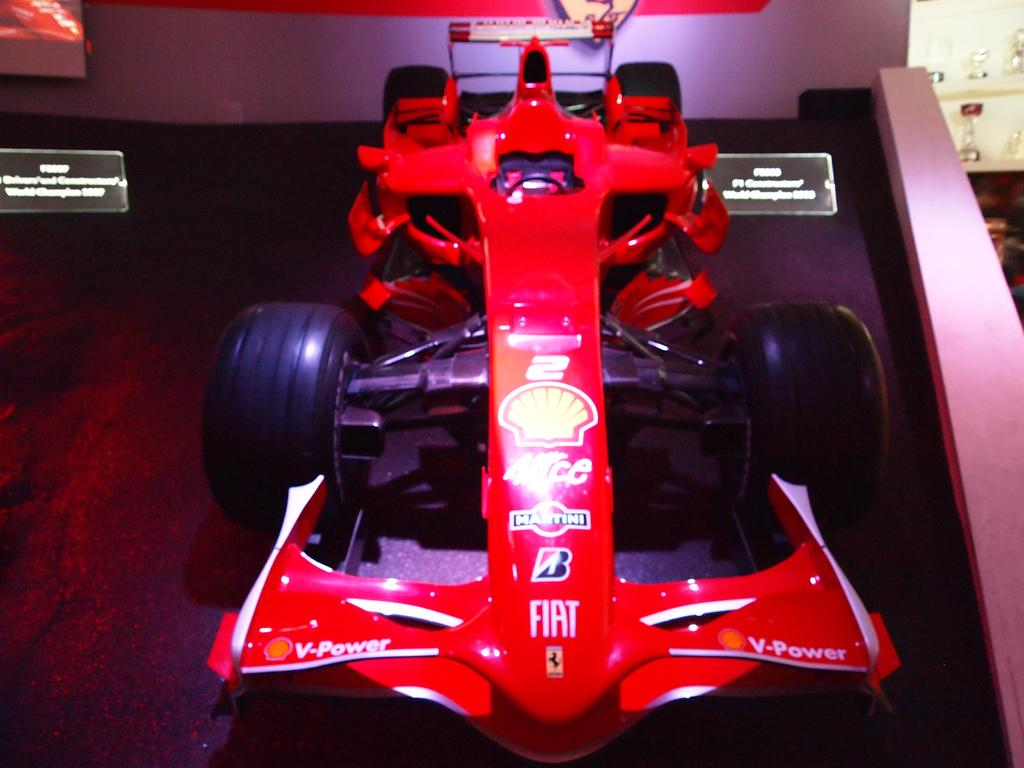What is placed on the floor in the image? There is a car on the floor in the image. What type of material can be seen in the image? Boards are visible in the image. What is a prominent feature in the image? There is a wall in the image. What can be seen in the distance in the image? There are objects in the background of the image. What is the income of the person in the image? There is no person present in the image, so it is not possible to determine their income. Who is the partner of the person in the image? There is no person present in the image, so it is not possible to determine their partner. 